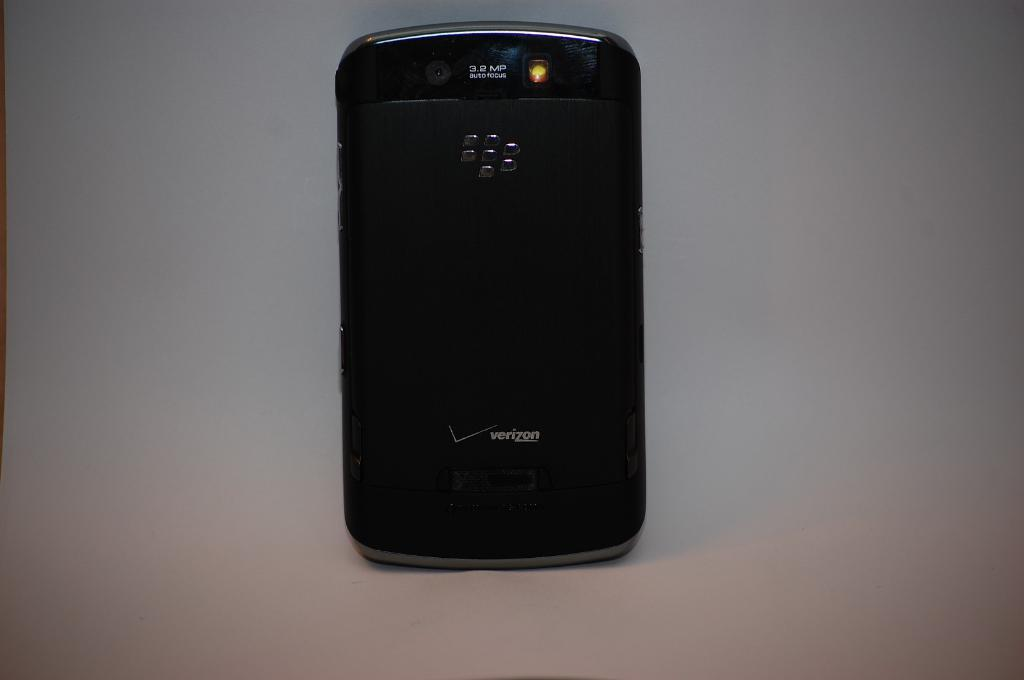<image>
Provide a brief description of the given image. A black phone has a Verizon logo on the back. 